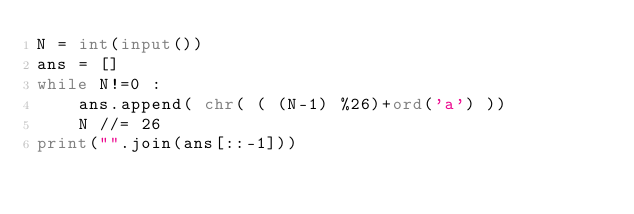Convert code to text. <code><loc_0><loc_0><loc_500><loc_500><_Python_>N = int(input())
ans = []
while N!=0 :
    ans.append( chr( ( (N-1) %26)+ord('a') ))
    N //= 26
print("".join(ans[::-1])) 
</code> 